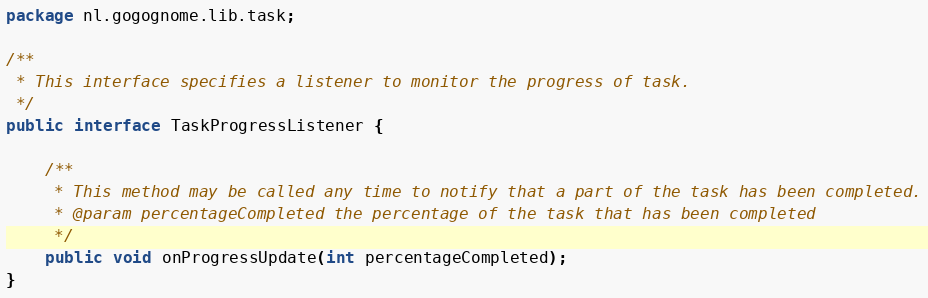<code> <loc_0><loc_0><loc_500><loc_500><_Java_>package nl.gogognome.lib.task;

/**
 * This interface specifies a listener to monitor the progress of task.
 */
public interface TaskProgressListener {

	/**
	 * This method may be called any time to notify that a part of the task has been completed.
	 * @param percentageCompleted the percentage of the task that has been completed
	 */
	public void onProgressUpdate(int percentageCompleted);
}
</code> 